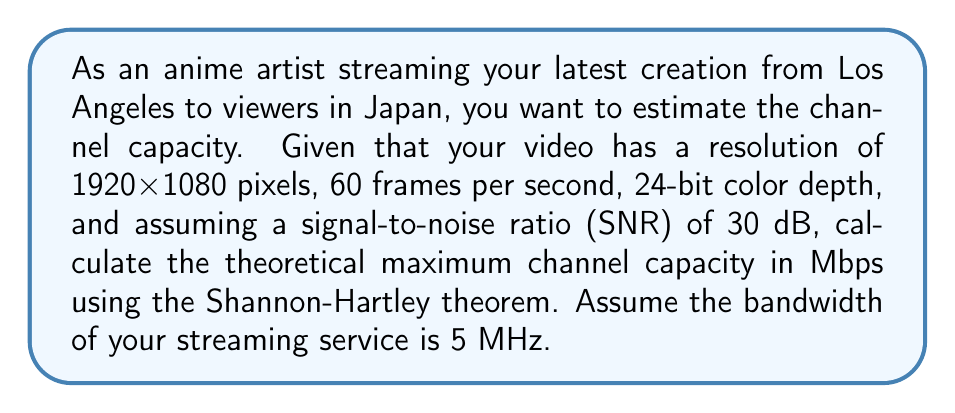Help me with this question. To solve this problem, we'll use the Shannon-Hartley theorem and follow these steps:

1. Calculate the raw data rate of the video stream:
   $$ \text{Data rate} = \text{Resolution} \times \text{Frame rate} \times \text{Color depth} $$
   $$ = (1920 \times 1080) \times 60 \times 24 = 2,985,984,000 \text{ bits/s} \approx 2986 \text{ Mbps} $$

2. Use the Shannon-Hartley theorem to calculate the channel capacity:
   $$ C = B \log_2(1 + \text{SNR}) $$
   Where:
   $C$ is the channel capacity in bits per second
   $B$ is the bandwidth in Hz
   $\text{SNR}$ is the signal-to-noise ratio

3. Convert the given SNR from dB to a linear scale:
   $$ \text{SNR}_{\text{linear}} = 10^{\frac{\text{SNR}_{\text{dB}}}{10}} = 10^{\frac{30}{10}} = 1000 $$

4. Apply the Shannon-Hartley theorem:
   $$ C = 5 \times 10^6 \times \log_2(1 + 1000) $$
   $$ = 5 \times 10^6 \times \log_2(1001) $$
   $$ \approx 5 \times 10^6 \times 9.97 $$
   $$ \approx 49.85 \times 10^6 \text{ bits/s} $$
   $$ \approx 49.85 \text{ Mbps} $$

5. Convert the result to Mbps:
   $$ 49.85 \text{ Mbps} $$

This theoretical maximum channel capacity (49.85 Mbps) is significantly lower than the raw data rate of the video (2986 Mbps), indicating that compression would be necessary for effective streaming.
Answer: 49.85 Mbps 